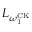Convert formula to latex. <formula><loc_0><loc_0><loc_500><loc_500>L _ { \omega _ { 1 } ^ { C K } }</formula> 